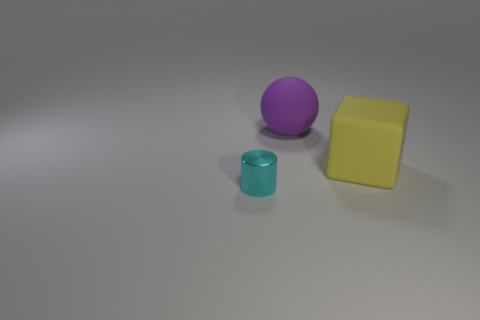Is there any other thing that has the same material as the small cyan cylinder?
Your response must be concise. No. What number of other objects are the same material as the block?
Offer a very short reply. 1. What is the color of the rubber object left of the large object that is on the right side of the large object on the left side of the large yellow cube?
Ensure brevity in your answer.  Purple. There is a object that is the same size as the matte block; what material is it?
Offer a terse response. Rubber. How many objects are objects on the right side of the tiny cyan shiny object or cyan cylinders?
Give a very brief answer. 3. Are there any small cyan metal cylinders?
Your answer should be compact. Yes. There is a object that is in front of the large yellow rubber block; what is its material?
Provide a short and direct response. Metal. How many tiny things are purple matte objects or yellow matte balls?
Offer a very short reply. 0. What is the color of the large ball?
Offer a very short reply. Purple. There is a matte object behind the rubber cube; are there any large matte objects on the right side of it?
Ensure brevity in your answer.  Yes. 